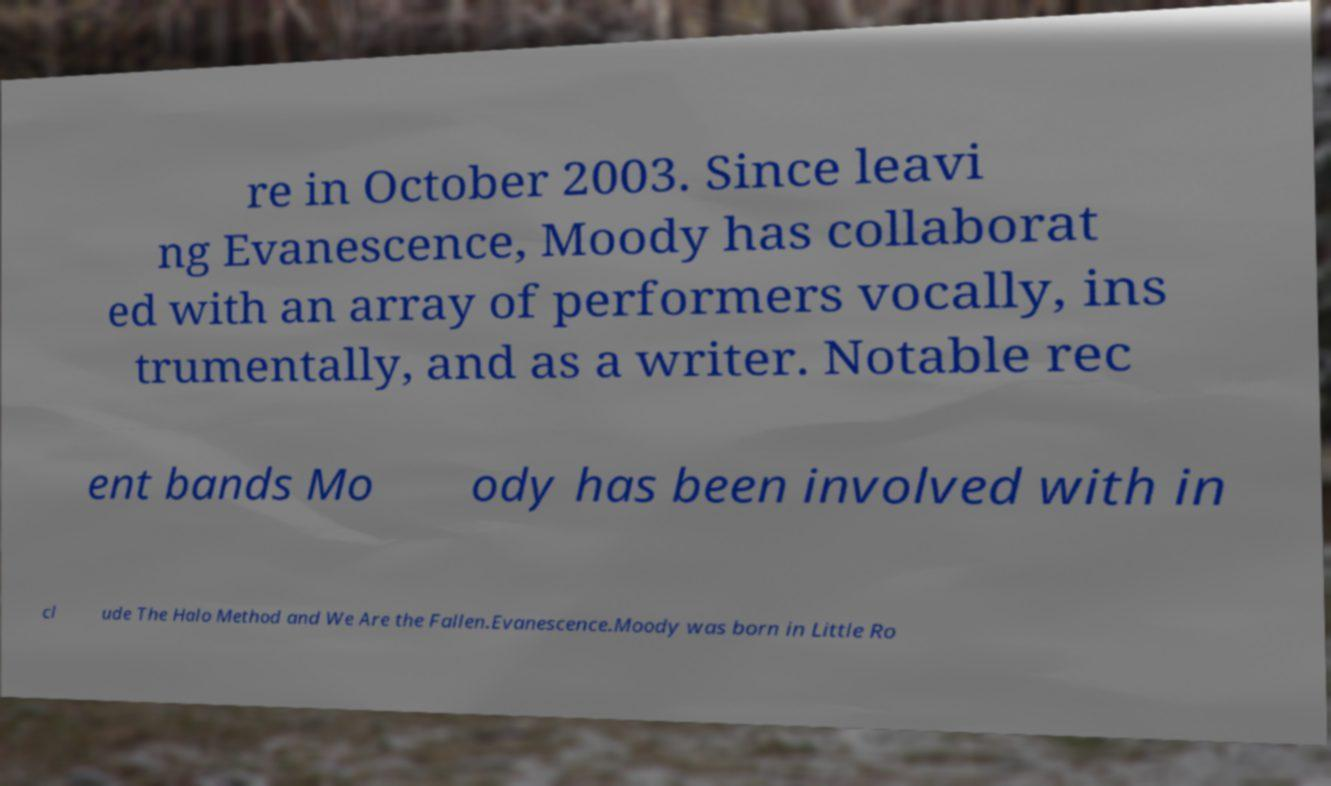Can you accurately transcribe the text from the provided image for me? re in October 2003. Since leavi ng Evanescence, Moody has collaborat ed with an array of performers vocally, ins trumentally, and as a writer. Notable rec ent bands Mo ody has been involved with in cl ude The Halo Method and We Are the Fallen.Evanescence.Moody was born in Little Ro 